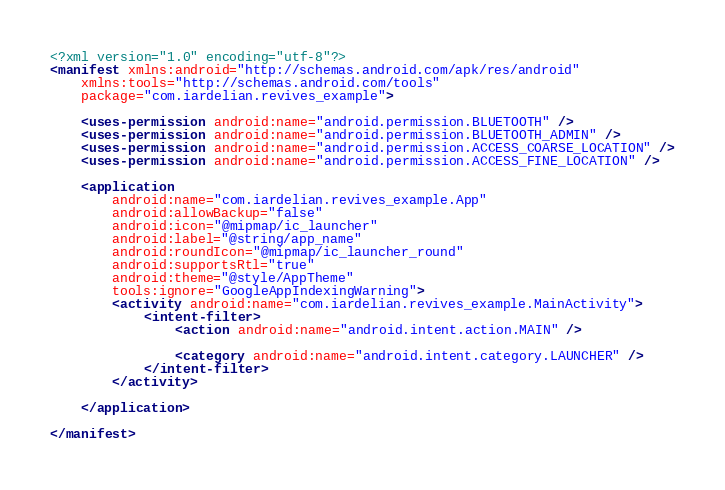<code> <loc_0><loc_0><loc_500><loc_500><_XML_><?xml version="1.0" encoding="utf-8"?>
<manifest xmlns:android="http://schemas.android.com/apk/res/android"
    xmlns:tools="http://schemas.android.com/tools"
    package="com.iardelian.revives_example">

    <uses-permission android:name="android.permission.BLUETOOTH" />
    <uses-permission android:name="android.permission.BLUETOOTH_ADMIN" />
    <uses-permission android:name="android.permission.ACCESS_COARSE_LOCATION" />
    <uses-permission android:name="android.permission.ACCESS_FINE_LOCATION" />

    <application
        android:name="com.iardelian.revives_example.App"
        android:allowBackup="false"
        android:icon="@mipmap/ic_launcher"
        android:label="@string/app_name"
        android:roundIcon="@mipmap/ic_launcher_round"
        android:supportsRtl="true"
        android:theme="@style/AppTheme"
        tools:ignore="GoogleAppIndexingWarning">
        <activity android:name="com.iardelian.revives_example.MainActivity">
            <intent-filter>
                <action android:name="android.intent.action.MAIN" />

                <category android:name="android.intent.category.LAUNCHER" />
            </intent-filter>
        </activity>

    </application>

</manifest></code> 